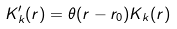<formula> <loc_0><loc_0><loc_500><loc_500>K ^ { \prime } _ { k } ( r ) = \theta ( r - r _ { 0 } ) K _ { k } ( r )</formula> 